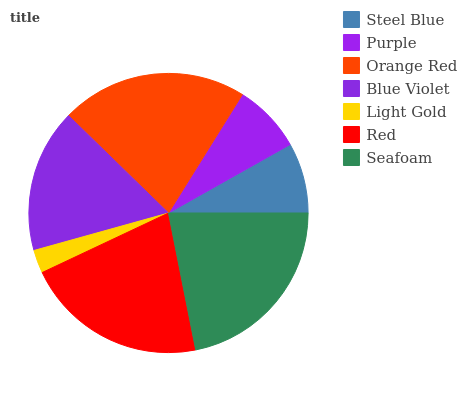Is Light Gold the minimum?
Answer yes or no. Yes. Is Seafoam the maximum?
Answer yes or no. Yes. Is Purple the minimum?
Answer yes or no. No. Is Purple the maximum?
Answer yes or no. No. Is Steel Blue greater than Purple?
Answer yes or no. Yes. Is Purple less than Steel Blue?
Answer yes or no. Yes. Is Purple greater than Steel Blue?
Answer yes or no. No. Is Steel Blue less than Purple?
Answer yes or no. No. Is Blue Violet the high median?
Answer yes or no. Yes. Is Blue Violet the low median?
Answer yes or no. Yes. Is Orange Red the high median?
Answer yes or no. No. Is Red the low median?
Answer yes or no. No. 